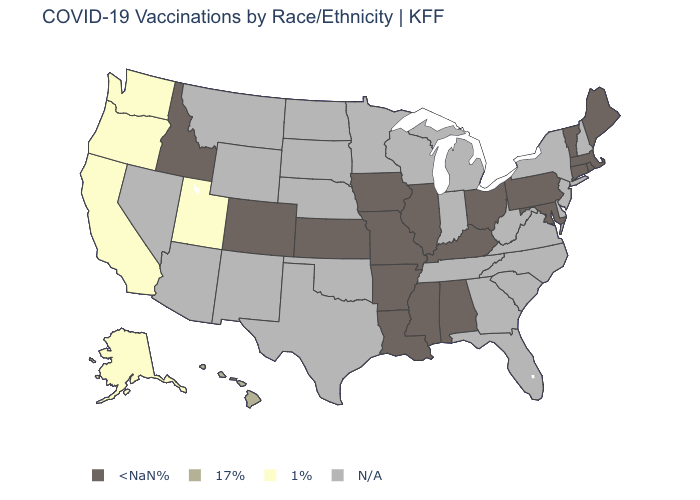What is the lowest value in the Northeast?
Be succinct. <NaN%. What is the value of Missouri?
Give a very brief answer. <NaN%. What is the lowest value in the USA?
Concise answer only. 1%. Does the map have missing data?
Concise answer only. Yes. What is the lowest value in the USA?
Keep it brief. 1%. What is the value of Maine?
Be succinct. <NaN%. Name the states that have a value in the range 1%?
Be succinct. Alaska, California, Oregon, Utah, Washington. Does Hawaii have the lowest value in the West?
Write a very short answer. No. What is the value of Wyoming?
Write a very short answer. N/A. Among the states that border Iowa , which have the lowest value?
Answer briefly. Illinois, Missouri. Among the states that border Nevada , does Idaho have the lowest value?
Be succinct. No. What is the value of Kansas?
Keep it brief. <NaN%. 